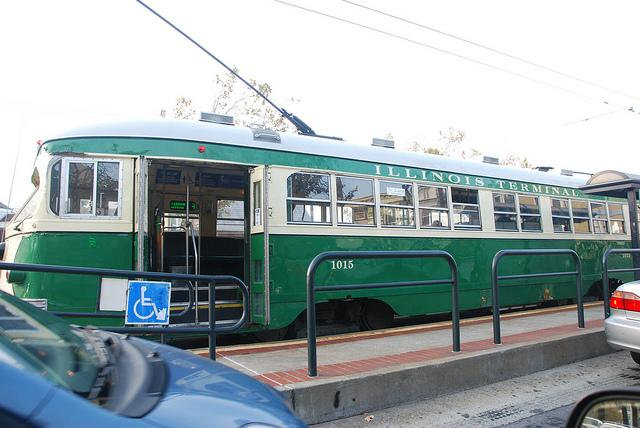What is available according to the blue sign? Please explain your reasoning. handicap seats. The blue sign with the person in a wheelchair symbol means that there is special access and seating. 